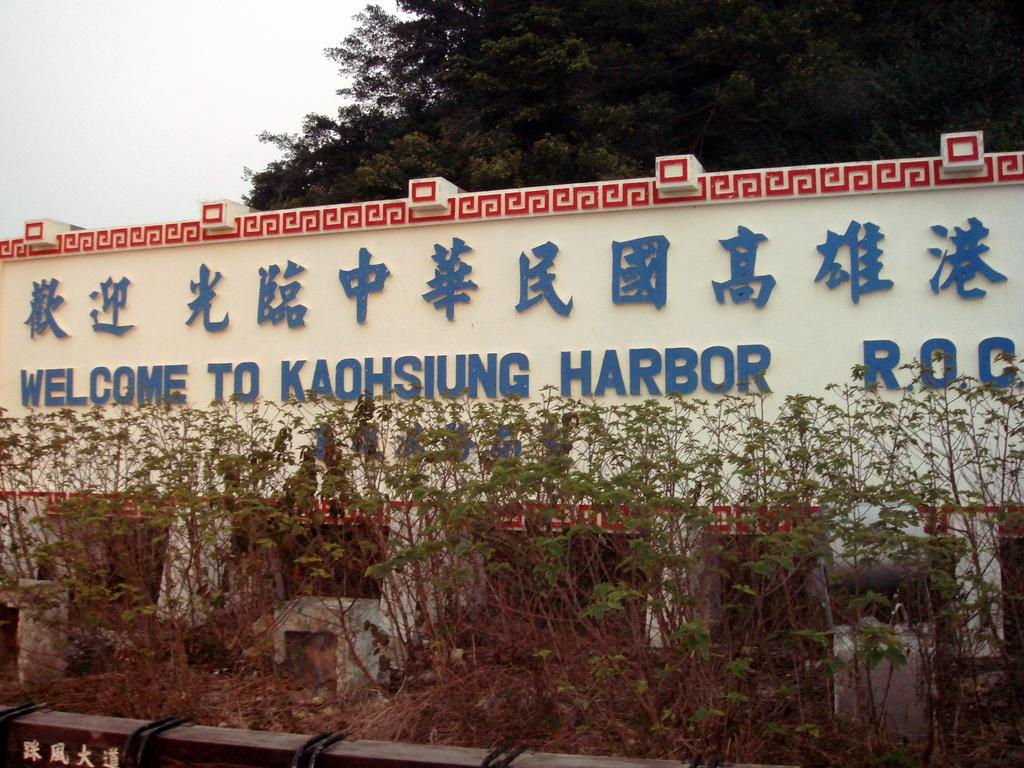What is written on the wall in the image? There is text on the wall in the image. What other natural elements can be seen in the image? There are plants and trees in the image. What is visible in the background of the image? The sky is visible in the image. What type of text is present in the bottom left corner of the image? There is text in a different language in the bottom left corner of the image. How many bears are holding crayons in the image? There are no bears or crayons present in the image. What color is the button on the wall in the image? There is no button present in the image. 